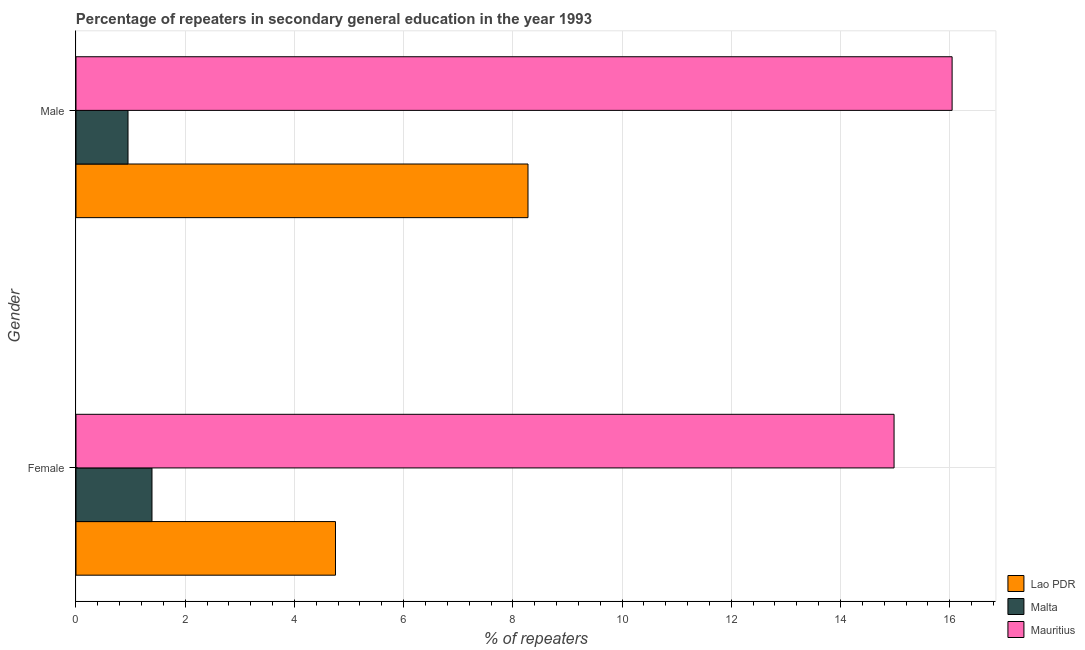How many different coloured bars are there?
Offer a terse response. 3. Are the number of bars on each tick of the Y-axis equal?
Ensure brevity in your answer.  Yes. How many bars are there on the 2nd tick from the top?
Your answer should be compact. 3. How many bars are there on the 1st tick from the bottom?
Your answer should be very brief. 3. What is the percentage of male repeaters in Lao PDR?
Your answer should be very brief. 8.28. Across all countries, what is the maximum percentage of male repeaters?
Provide a succinct answer. 16.04. Across all countries, what is the minimum percentage of female repeaters?
Your response must be concise. 1.39. In which country was the percentage of male repeaters maximum?
Offer a very short reply. Mauritius. In which country was the percentage of female repeaters minimum?
Your answer should be compact. Malta. What is the total percentage of female repeaters in the graph?
Make the answer very short. 21.12. What is the difference between the percentage of male repeaters in Malta and that in Mauritius?
Offer a terse response. -15.09. What is the difference between the percentage of male repeaters in Lao PDR and the percentage of female repeaters in Mauritius?
Give a very brief answer. -6.7. What is the average percentage of male repeaters per country?
Offer a terse response. 8.42. What is the difference between the percentage of male repeaters and percentage of female repeaters in Mauritius?
Offer a very short reply. 1.06. What is the ratio of the percentage of female repeaters in Lao PDR to that in Malta?
Keep it short and to the point. 3.41. Is the percentage of male repeaters in Lao PDR less than that in Mauritius?
Ensure brevity in your answer.  Yes. In how many countries, is the percentage of male repeaters greater than the average percentage of male repeaters taken over all countries?
Offer a very short reply. 1. What does the 3rd bar from the top in Male represents?
Provide a succinct answer. Lao PDR. What does the 3rd bar from the bottom in Female represents?
Offer a very short reply. Mauritius. What is the difference between two consecutive major ticks on the X-axis?
Offer a very short reply. 2. Does the graph contain any zero values?
Offer a terse response. No. How many legend labels are there?
Provide a short and direct response. 3. What is the title of the graph?
Offer a terse response. Percentage of repeaters in secondary general education in the year 1993. Does "Malawi" appear as one of the legend labels in the graph?
Make the answer very short. No. What is the label or title of the X-axis?
Give a very brief answer. % of repeaters. What is the % of repeaters of Lao PDR in Female?
Offer a very short reply. 4.75. What is the % of repeaters in Malta in Female?
Your answer should be very brief. 1.39. What is the % of repeaters in Mauritius in Female?
Offer a very short reply. 14.98. What is the % of repeaters in Lao PDR in Male?
Make the answer very short. 8.28. What is the % of repeaters in Malta in Male?
Keep it short and to the point. 0.95. What is the % of repeaters of Mauritius in Male?
Your answer should be compact. 16.04. Across all Gender, what is the maximum % of repeaters in Lao PDR?
Keep it short and to the point. 8.28. Across all Gender, what is the maximum % of repeaters in Malta?
Keep it short and to the point. 1.39. Across all Gender, what is the maximum % of repeaters in Mauritius?
Your answer should be very brief. 16.04. Across all Gender, what is the minimum % of repeaters of Lao PDR?
Ensure brevity in your answer.  4.75. Across all Gender, what is the minimum % of repeaters in Malta?
Your response must be concise. 0.95. Across all Gender, what is the minimum % of repeaters of Mauritius?
Make the answer very short. 14.98. What is the total % of repeaters of Lao PDR in the graph?
Make the answer very short. 13.03. What is the total % of repeaters of Malta in the graph?
Your response must be concise. 2.34. What is the total % of repeaters of Mauritius in the graph?
Give a very brief answer. 31.03. What is the difference between the % of repeaters in Lao PDR in Female and that in Male?
Provide a short and direct response. -3.53. What is the difference between the % of repeaters in Malta in Female and that in Male?
Give a very brief answer. 0.44. What is the difference between the % of repeaters of Mauritius in Female and that in Male?
Offer a very short reply. -1.06. What is the difference between the % of repeaters in Lao PDR in Female and the % of repeaters in Malta in Male?
Provide a short and direct response. 3.8. What is the difference between the % of repeaters of Lao PDR in Female and the % of repeaters of Mauritius in Male?
Your answer should be compact. -11.29. What is the difference between the % of repeaters of Malta in Female and the % of repeaters of Mauritius in Male?
Offer a terse response. -14.65. What is the average % of repeaters of Lao PDR per Gender?
Ensure brevity in your answer.  6.51. What is the average % of repeaters of Malta per Gender?
Ensure brevity in your answer.  1.17. What is the average % of repeaters in Mauritius per Gender?
Provide a succinct answer. 15.51. What is the difference between the % of repeaters of Lao PDR and % of repeaters of Malta in Female?
Provide a short and direct response. 3.36. What is the difference between the % of repeaters in Lao PDR and % of repeaters in Mauritius in Female?
Provide a short and direct response. -10.23. What is the difference between the % of repeaters of Malta and % of repeaters of Mauritius in Female?
Provide a succinct answer. -13.59. What is the difference between the % of repeaters in Lao PDR and % of repeaters in Malta in Male?
Make the answer very short. 7.32. What is the difference between the % of repeaters of Lao PDR and % of repeaters of Mauritius in Male?
Ensure brevity in your answer.  -7.77. What is the difference between the % of repeaters of Malta and % of repeaters of Mauritius in Male?
Keep it short and to the point. -15.09. What is the ratio of the % of repeaters in Lao PDR in Female to that in Male?
Your answer should be very brief. 0.57. What is the ratio of the % of repeaters of Malta in Female to that in Male?
Your answer should be compact. 1.46. What is the ratio of the % of repeaters of Mauritius in Female to that in Male?
Ensure brevity in your answer.  0.93. What is the difference between the highest and the second highest % of repeaters in Lao PDR?
Your answer should be very brief. 3.53. What is the difference between the highest and the second highest % of repeaters in Malta?
Provide a succinct answer. 0.44. What is the difference between the highest and the second highest % of repeaters of Mauritius?
Provide a succinct answer. 1.06. What is the difference between the highest and the lowest % of repeaters in Lao PDR?
Offer a terse response. 3.53. What is the difference between the highest and the lowest % of repeaters of Malta?
Your answer should be compact. 0.44. What is the difference between the highest and the lowest % of repeaters in Mauritius?
Make the answer very short. 1.06. 